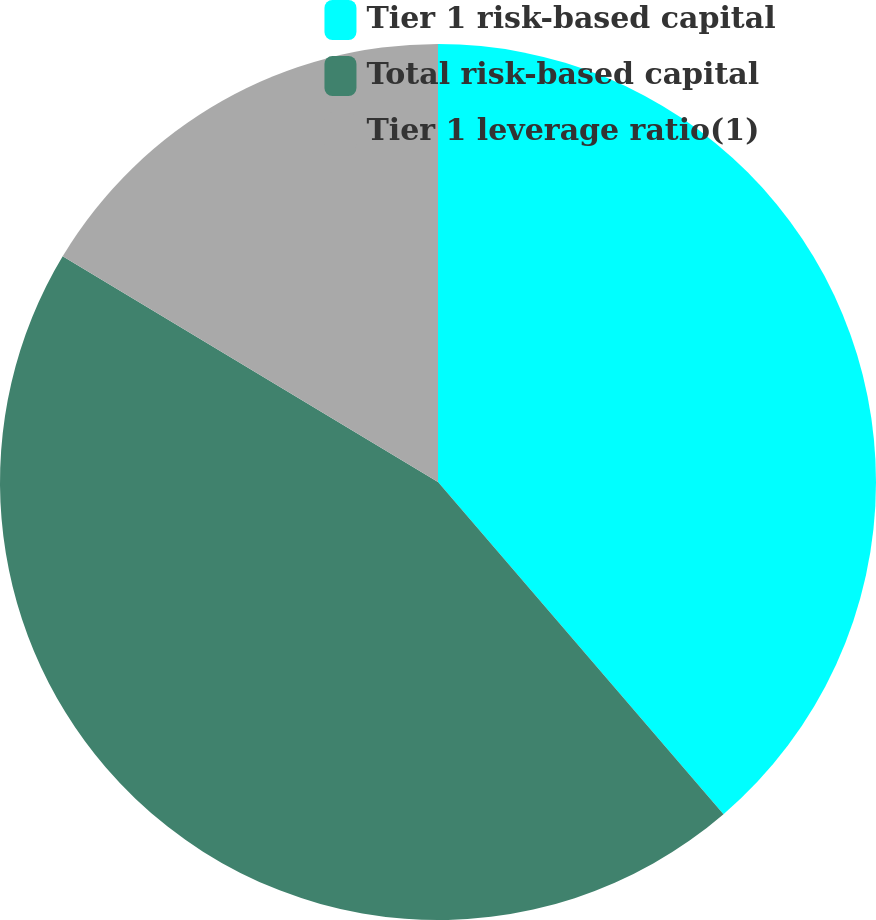Convert chart to OTSL. <chart><loc_0><loc_0><loc_500><loc_500><pie_chart><fcel>Tier 1 risk-based capital<fcel>Total risk-based capital<fcel>Tier 1 leverage ratio(1)<nl><fcel>38.7%<fcel>44.92%<fcel>16.38%<nl></chart> 